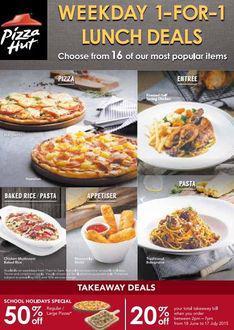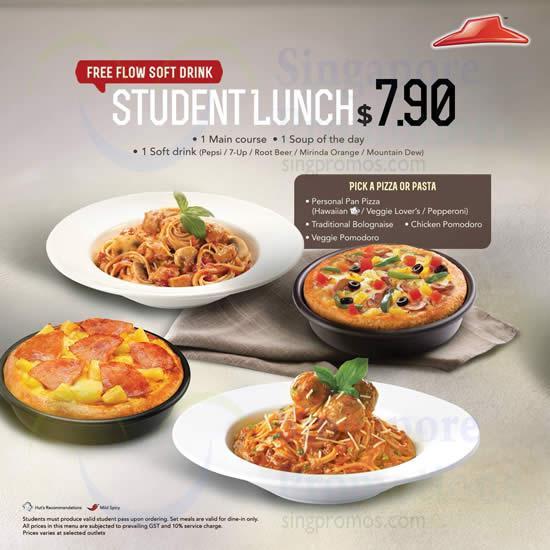The first image is the image on the left, the second image is the image on the right. Examine the images to the left and right. Is the description "The right image includes a cartoon clock and contains the same number of food items as the left image." accurate? Answer yes or no. No. The first image is the image on the left, the second image is the image on the right. Examine the images to the left and right. Is the description "In at least on image ad, there is both a pizza an at least three mozzarella sticks." accurate? Answer yes or no. Yes. 